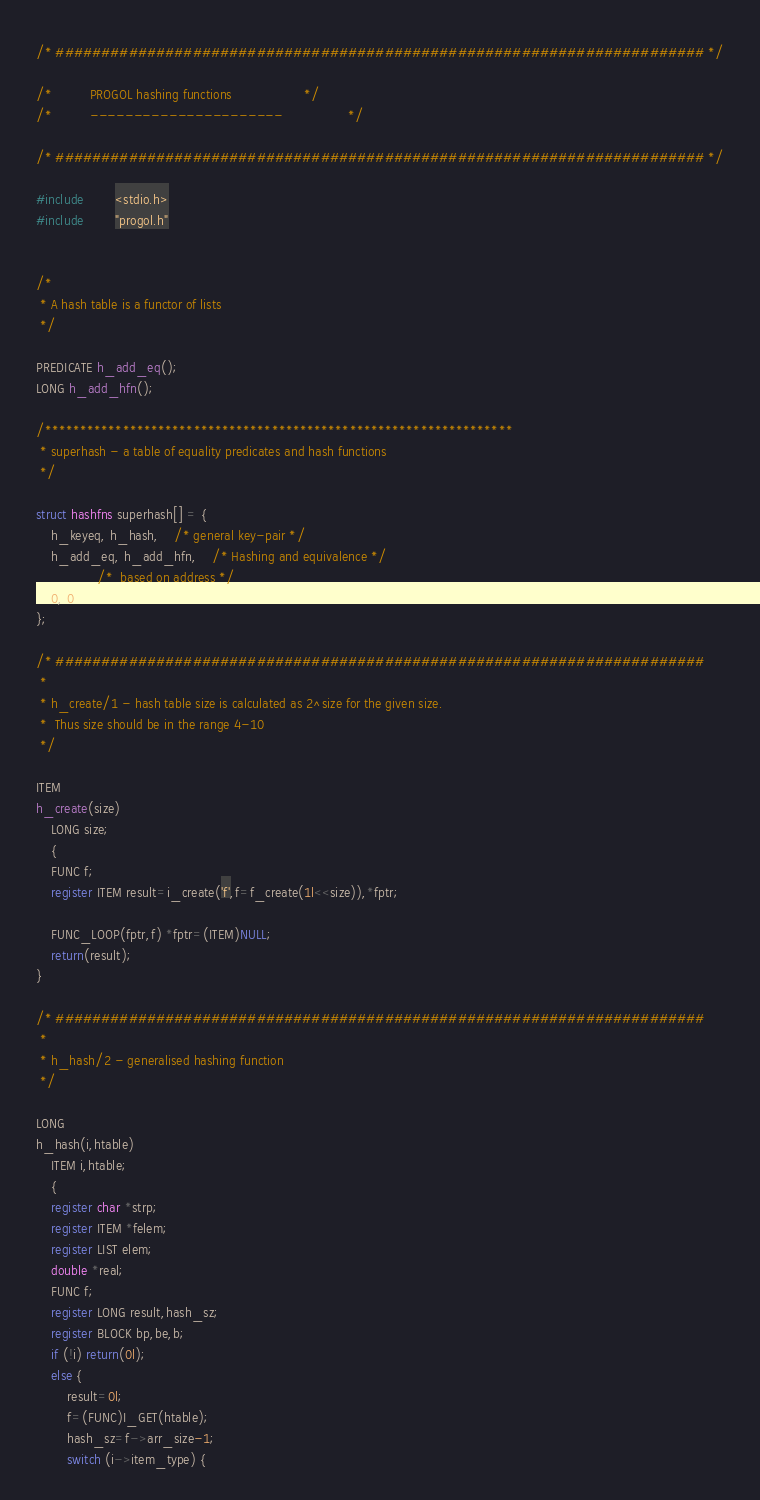Convert code to text. <code><loc_0><loc_0><loc_500><loc_500><_C_>/* ####################################################################### */

/*			PROGOL hashing functions				   */
/*			----------------------				   */

/* ####################################################################### */

#include        <stdio.h>
#include        "progol.h"


/*
 * A hash table is a functor of lists
 */

PREDICATE h_add_eq();
LONG h_add_hfn();

/******************************************************************
 * superhash - a table of equality predicates and hash functions
 */

struct hashfns superhash[] = {
	h_keyeq, h_hash,	/* general key-pair */
	h_add_eq, h_add_hfn,	/* Hashing and equivalence */
				/*  based on address */
	0, 0
};

/* #######################################################################
 *
 * h_create/1 - hash table size is calculated as 2^size for the given size.
 *	Thus size should be in the range 4-10
 */

ITEM
h_create(size)
	LONG size;
	{
	FUNC f;
	register ITEM result=i_create('f',f=f_create(1l<<size)),*fptr;
	
	FUNC_LOOP(fptr,f) *fptr=(ITEM)NULL; 
	return(result);
}

/* ####################################################################### 
 *
 * h_hash/2 - generalised hashing function
 */

LONG
h_hash(i,htable)
	ITEM i,htable;
	{
	register char *strp;
	register ITEM *felem;
	register LIST elem;
	double *real;
	FUNC f;
	register LONG result,hash_sz;
	register BLOCK bp,be,b;
	if (!i) return(0l);
	else {
		result=0l;
		f=(FUNC)I_GET(htable);
		hash_sz=f->arr_size-1;
		switch (i->item_type) {</code> 